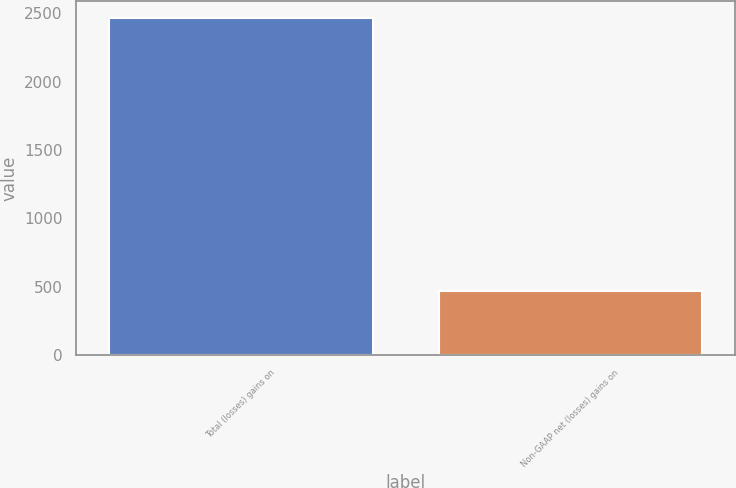<chart> <loc_0><loc_0><loc_500><loc_500><bar_chart><fcel>Total (losses) gains on<fcel>Non-GAAP net (losses) gains on<nl><fcel>2467<fcel>471<nl></chart> 